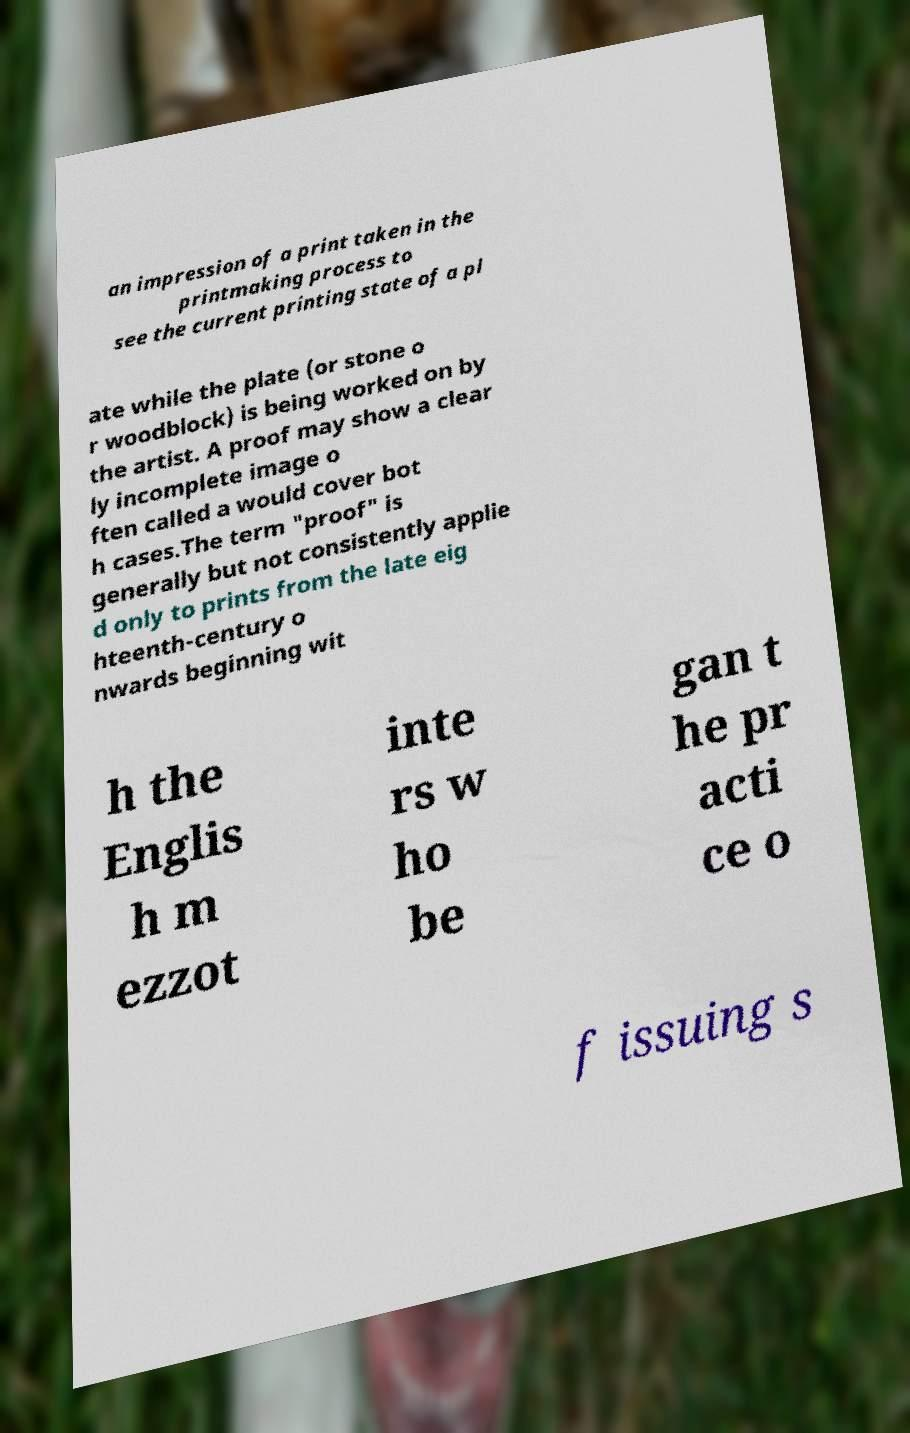I need the written content from this picture converted into text. Can you do that? an impression of a print taken in the printmaking process to see the current printing state of a pl ate while the plate (or stone o r woodblock) is being worked on by the artist. A proof may show a clear ly incomplete image o ften called a would cover bot h cases.The term "proof" is generally but not consistently applie d only to prints from the late eig hteenth-century o nwards beginning wit h the Englis h m ezzot inte rs w ho be gan t he pr acti ce o f issuing s 